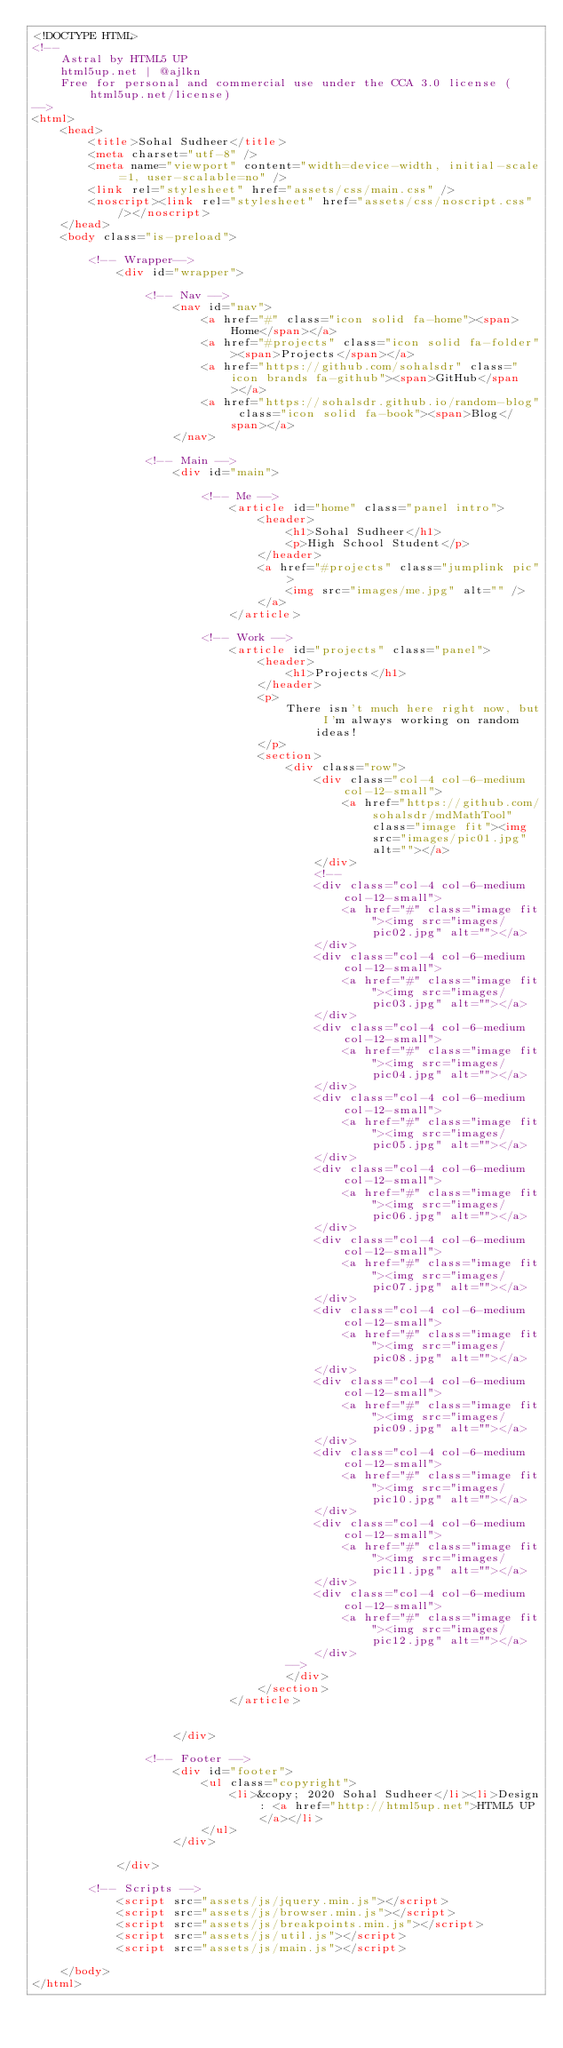<code> <loc_0><loc_0><loc_500><loc_500><_HTML_><!DOCTYPE HTML>
<!--
	Astral by HTML5 UP
	html5up.net | @ajlkn
	Free for personal and commercial use under the CCA 3.0 license (html5up.net/license)
-->
<html>
	<head>
		<title>Sohal Sudheer</title>
		<meta charset="utf-8" />
		<meta name="viewport" content="width=device-width, initial-scale=1, user-scalable=no" />
		<link rel="stylesheet" href="assets/css/main.css" />
		<noscript><link rel="stylesheet" href="assets/css/noscript.css" /></noscript>
	</head>
	<body class="is-preload">

		<!-- Wrapper-->
			<div id="wrapper">

				<!-- Nav -->
					<nav id="nav">
						<a href="#" class="icon solid fa-home"><span>Home</span></a>
						<a href="#projects" class="icon solid fa-folder"><span>Projects</span></a>
						<a href="https://github.com/sohalsdr" class="icon brands fa-github"><span>GitHub</span></a>
						<a href="https://sohalsdr.github.io/random-blog" class="icon solid fa-book"><span>Blog</span></a>
					</nav>

				<!-- Main -->
					<div id="main">

						<!-- Me -->
							<article id="home" class="panel intro">
								<header>
									<h1>Sohal Sudheer</h1>
									<p>High School Student</p>
								</header>
								<a href="#projects" class="jumplink pic">
									<img src="images/me.jpg" alt="" />
								</a>
							</article>

						<!-- Work -->
							<article id="projects" class="panel">
								<header>
									<h1>Projects</h1>
								</header>
								<p>
									There isn't much here right now, but I'm always working on random ideas!
								</p>
								<section>
									<div class="row">
										<div class="col-4 col-6-medium col-12-small">
											<a href="https://github.com/sohalsdr/mdMathTool" class="image fit"><img src="images/pic01.jpg" alt=""></a>
										</div>
										<!--
										<div class="col-4 col-6-medium col-12-small">
											<a href="#" class="image fit"><img src="images/pic02.jpg" alt=""></a>
										</div>
										<div class="col-4 col-6-medium col-12-small">
											<a href="#" class="image fit"><img src="images/pic03.jpg" alt=""></a>
										</div>
										<div class="col-4 col-6-medium col-12-small">
											<a href="#" class="image fit"><img src="images/pic04.jpg" alt=""></a>
										</div>
										<div class="col-4 col-6-medium col-12-small">
											<a href="#" class="image fit"><img src="images/pic05.jpg" alt=""></a>
										</div>
										<div class="col-4 col-6-medium col-12-small">
											<a href="#" class="image fit"><img src="images/pic06.jpg" alt=""></a>
										</div>
										<div class="col-4 col-6-medium col-12-small">
											<a href="#" class="image fit"><img src="images/pic07.jpg" alt=""></a>
										</div>
										<div class="col-4 col-6-medium col-12-small">
											<a href="#" class="image fit"><img src="images/pic08.jpg" alt=""></a>
										</div>
										<div class="col-4 col-6-medium col-12-small">
											<a href="#" class="image fit"><img src="images/pic09.jpg" alt=""></a>
										</div>
										<div class="col-4 col-6-medium col-12-small">
											<a href="#" class="image fit"><img src="images/pic10.jpg" alt=""></a>
										</div>
										<div class="col-4 col-6-medium col-12-small">
											<a href="#" class="image fit"><img src="images/pic11.jpg" alt=""></a>
										</div>
										<div class="col-4 col-6-medium col-12-small">
											<a href="#" class="image fit"><img src="images/pic12.jpg" alt=""></a>
										</div>
									-->
									</div>
								</section>
							</article>


					</div>

				<!-- Footer -->
					<div id="footer">
						<ul class="copyright">
							<li>&copy; 2020 Sohal Sudheer</li><li>Design: <a href="http://html5up.net">HTML5 UP</a></li>
						</ul>
					</div>

			</div>

		<!-- Scripts -->
			<script src="assets/js/jquery.min.js"></script>
			<script src="assets/js/browser.min.js"></script>
			<script src="assets/js/breakpoints.min.js"></script>
			<script src="assets/js/util.js"></script>
			<script src="assets/js/main.js"></script>

	</body>
</html>
</code> 